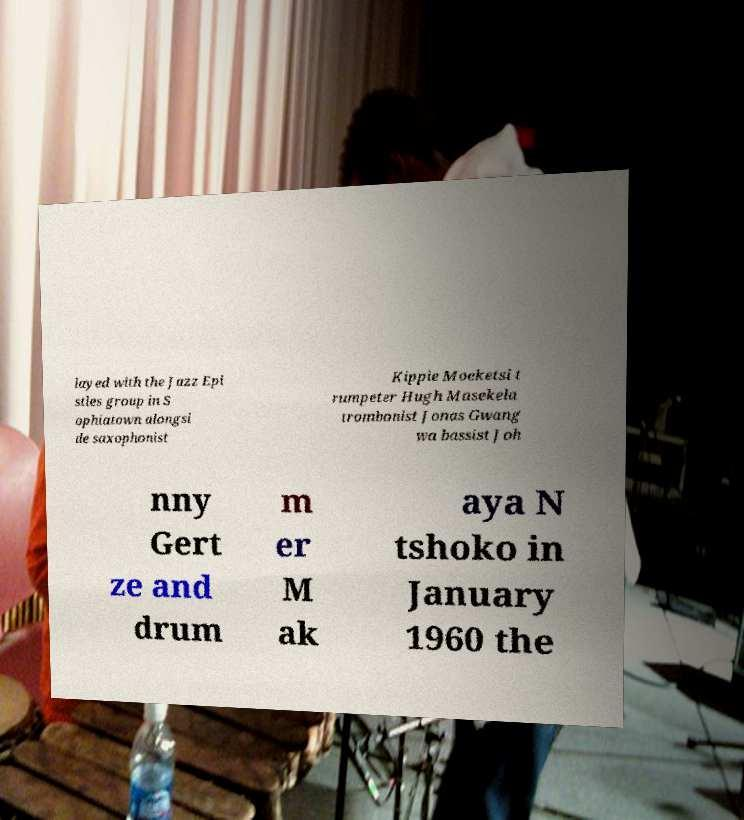There's text embedded in this image that I need extracted. Can you transcribe it verbatim? layed with the Jazz Epi stles group in S ophiatown alongsi de saxophonist Kippie Moeketsi t rumpeter Hugh Masekela trombonist Jonas Gwang wa bassist Joh nny Gert ze and drum m er M ak aya N tshoko in January 1960 the 